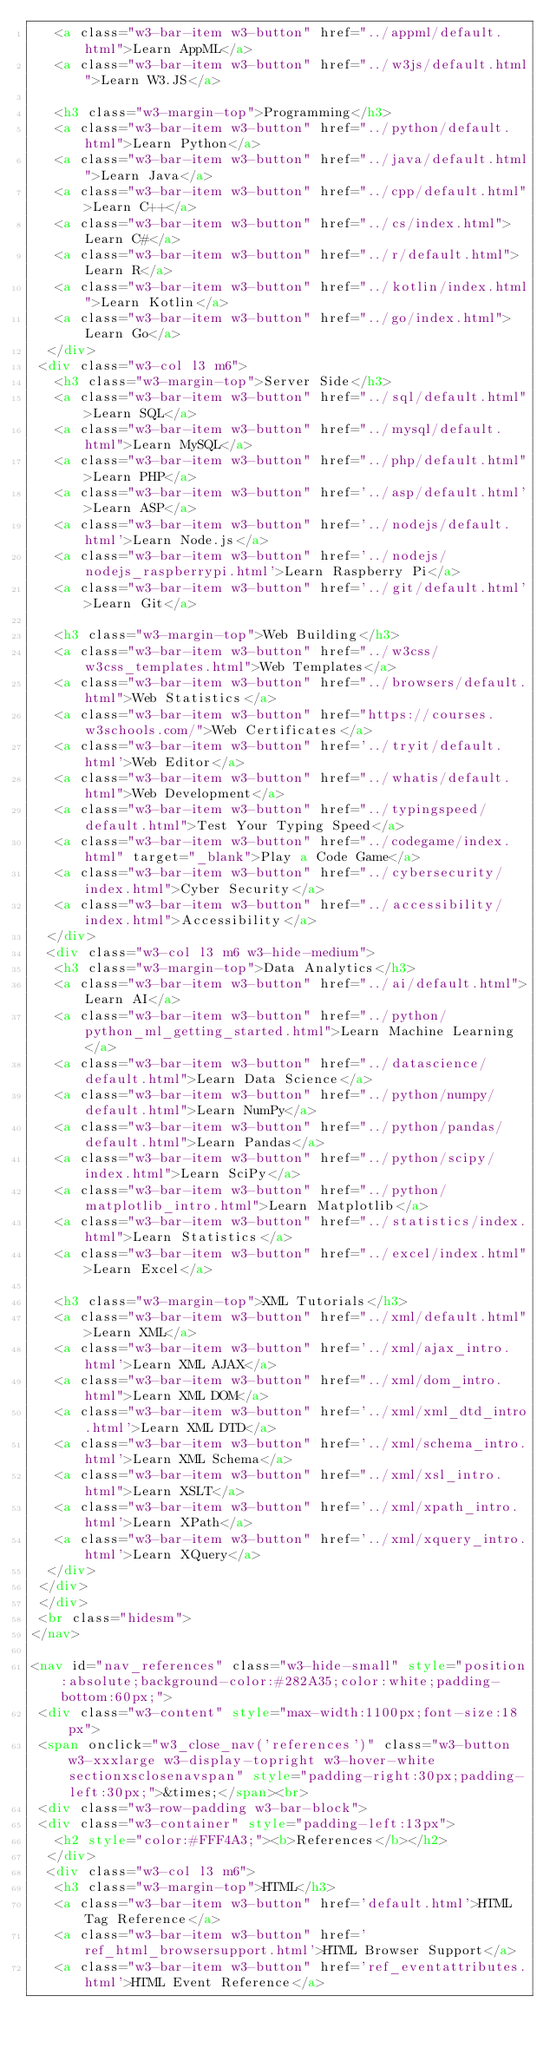<code> <loc_0><loc_0><loc_500><loc_500><_HTML_>   <a class="w3-bar-item w3-button" href="../appml/default.html">Learn AppML</a>
   <a class="w3-bar-item w3-button" href="../w3js/default.html">Learn W3.JS</a>

   <h3 class="w3-margin-top">Programming</h3>
   <a class="w3-bar-item w3-button" href="../python/default.html">Learn Python</a>
   <a class="w3-bar-item w3-button" href="../java/default.html">Learn Java</a>
   <a class="w3-bar-item w3-button" href="../cpp/default.html">Learn C++</a>
   <a class="w3-bar-item w3-button" href="../cs/index.html">Learn C#</a>
   <a class="w3-bar-item w3-button" href="../r/default.html">Learn R</a>
   <a class="w3-bar-item w3-button" href="../kotlin/index.html">Learn Kotlin</a>
   <a class="w3-bar-item w3-button" href="../go/index.html">Learn Go</a>
  </div> 
 <div class="w3-col l3 m6">
   <h3 class="w3-margin-top">Server Side</h3>
   <a class="w3-bar-item w3-button" href="../sql/default.html">Learn SQL</a>
   <a class="w3-bar-item w3-button" href="../mysql/default.html">Learn MySQL</a>
   <a class="w3-bar-item w3-button" href="../php/default.html">Learn PHP</a>
   <a class="w3-bar-item w3-button" href='../asp/default.html'>Learn ASP</a>
   <a class="w3-bar-item w3-button" href='../nodejs/default.html'>Learn Node.js</a>
   <a class="w3-bar-item w3-button" href='../nodejs/nodejs_raspberrypi.html'>Learn Raspberry Pi</a>
   <a class="w3-bar-item w3-button" href='../git/default.html'>Learn Git</a>

   <h3 class="w3-margin-top">Web Building</h3>
   <a class="w3-bar-item w3-button" href="../w3css/w3css_templates.html">Web Templates</a>
   <a class="w3-bar-item w3-button" href="../browsers/default.html">Web Statistics</a>
   <a class="w3-bar-item w3-button" href="https://courses.w3schools.com/">Web Certificates</a>
   <a class="w3-bar-item w3-button" href='../tryit/default.html'>Web Editor</a>
   <a class="w3-bar-item w3-button" href="../whatis/default.html">Web Development</a>
   <a class="w3-bar-item w3-button" href="../typingspeed/default.html">Test Your Typing Speed</a>
   <a class="w3-bar-item w3-button" href="../codegame/index.html" target="_blank">Play a Code Game</a>
   <a class="w3-bar-item w3-button" href="../cybersecurity/index.html">Cyber Security</a>
   <a class="w3-bar-item w3-button" href="../accessibility/index.html">Accessibility</a>
  </div>
  <div class="w3-col l3 m6 w3-hide-medium">
   <h3 class="w3-margin-top">Data Analytics</h3>
   <a class="w3-bar-item w3-button" href="../ai/default.html">Learn AI</a>
   <a class="w3-bar-item w3-button" href="../python/python_ml_getting_started.html">Learn Machine Learning</a>
   <a class="w3-bar-item w3-button" href="../datascience/default.html">Learn Data Science</a> 
   <a class="w3-bar-item w3-button" href="../python/numpy/default.html">Learn NumPy</a>    
   <a class="w3-bar-item w3-button" href="../python/pandas/default.html">Learn Pandas</a>    
   <a class="w3-bar-item w3-button" href="../python/scipy/index.html">Learn SciPy</a>    
   <a class="w3-bar-item w3-button" href="../python/matplotlib_intro.html">Learn Matplotlib</a>    
   <a class="w3-bar-item w3-button" href="../statistics/index.html">Learn Statistics</a>
   <a class="w3-bar-item w3-button" href="../excel/index.html">Learn Excel</a>

   <h3 class="w3-margin-top">XML Tutorials</h3>
   <a class="w3-bar-item w3-button" href="../xml/default.html">Learn XML</a>
   <a class="w3-bar-item w3-button" href='../xml/ajax_intro.html'>Learn XML AJAX</a>
   <a class="w3-bar-item w3-button" href="../xml/dom_intro.html">Learn XML DOM</a>
   <a class="w3-bar-item w3-button" href='../xml/xml_dtd_intro.html'>Learn XML DTD</a>
   <a class="w3-bar-item w3-button" href='../xml/schema_intro.html'>Learn XML Schema</a>
   <a class="w3-bar-item w3-button" href="../xml/xsl_intro.html">Learn XSLT</a>
   <a class="w3-bar-item w3-button" href='../xml/xpath_intro.html'>Learn XPath</a>
   <a class="w3-bar-item w3-button" href='../xml/xquery_intro.html'>Learn XQuery</a>
  </div>
 </div>
 </div>
 <br class="hidesm">
</nav>

<nav id="nav_references" class="w3-hide-small" style="position:absolute;background-color:#282A35;color:white;padding-bottom:60px;">
 <div class="w3-content" style="max-width:1100px;font-size:18px">
 <span onclick="w3_close_nav('references')" class="w3-button w3-xxxlarge w3-display-topright w3-hover-white sectionxsclosenavspan" style="padding-right:30px;padding-left:30px;">&times;</span><br>
 <div class="w3-row-padding w3-bar-block">
 <div class="w3-container" style="padding-left:13px">
   <h2 style="color:#FFF4A3;"><b>References</b></h2>
  </div>
  <div class="w3-col l3 m6">
   <h3 class="w3-margin-top">HTML</h3>
   <a class="w3-bar-item w3-button" href='default.html'>HTML Tag Reference</a>
   <a class="w3-bar-item w3-button" href='ref_html_browsersupport.html'>HTML Browser Support</a>   
   <a class="w3-bar-item w3-button" href='ref_eventattributes.html'>HTML Event Reference</a></code> 